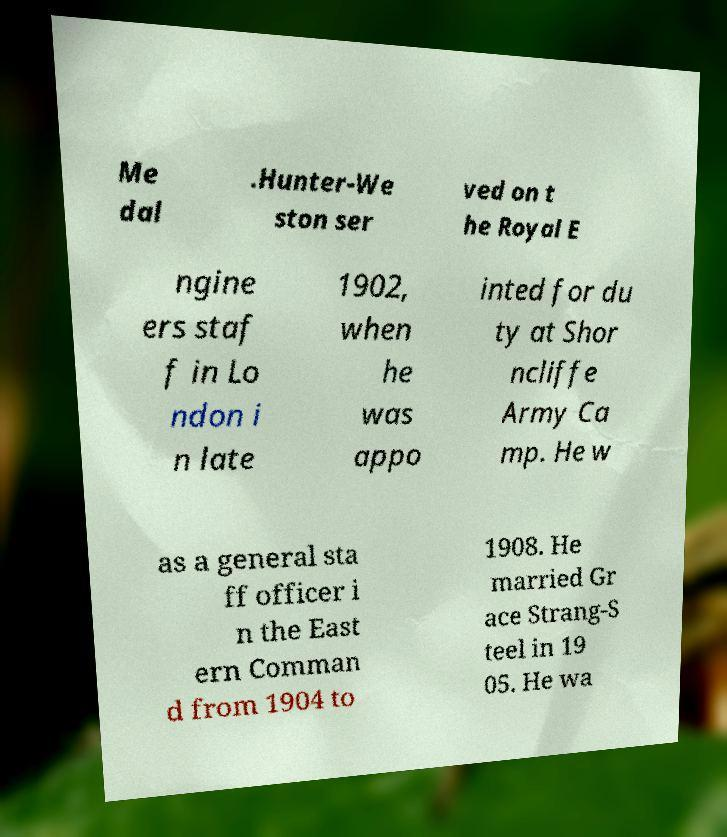Could you extract and type out the text from this image? Me dal .Hunter-We ston ser ved on t he Royal E ngine ers staf f in Lo ndon i n late 1902, when he was appo inted for du ty at Shor ncliffe Army Ca mp. He w as a general sta ff officer i n the East ern Comman d from 1904 to 1908. He married Gr ace Strang-S teel in 19 05. He wa 